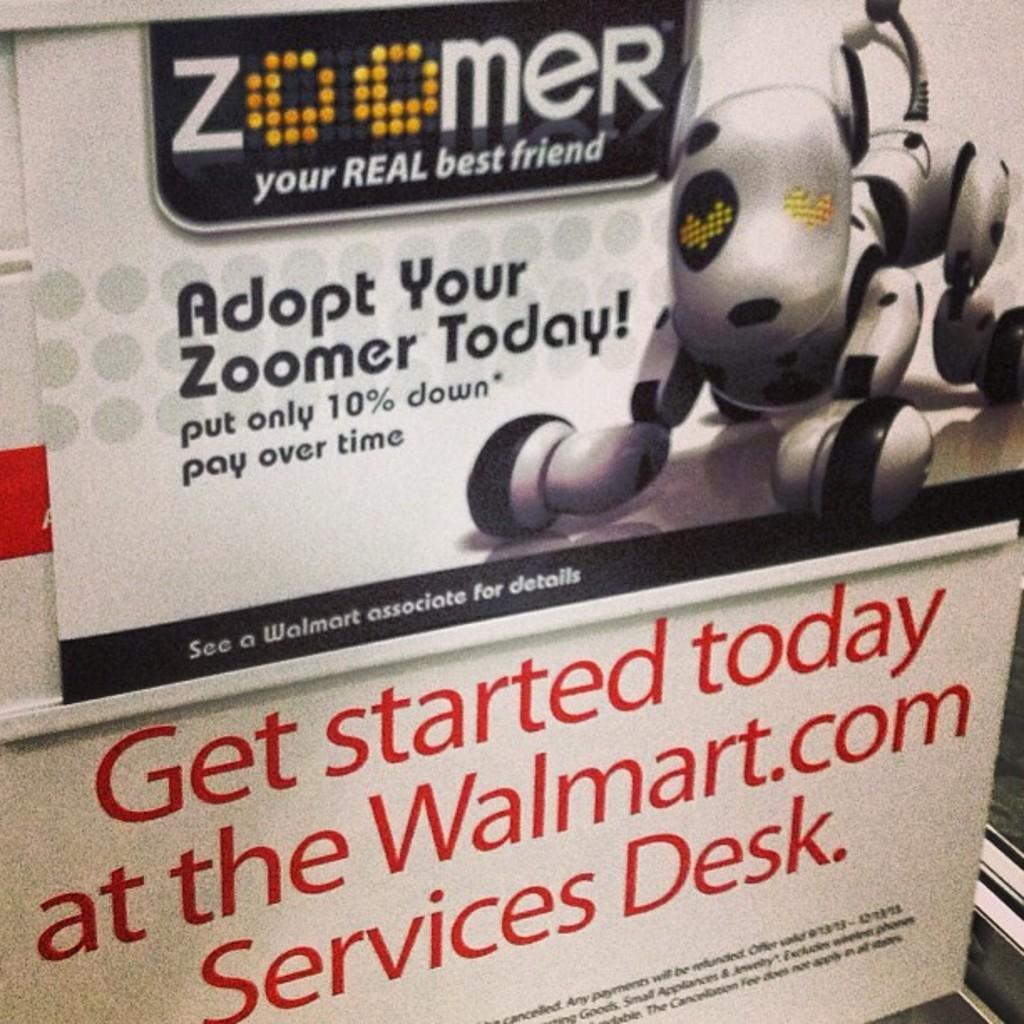<image>
Relay a brief, clear account of the picture shown. An ad for Zoomer is shown with instructions to go to the service desk as well. 